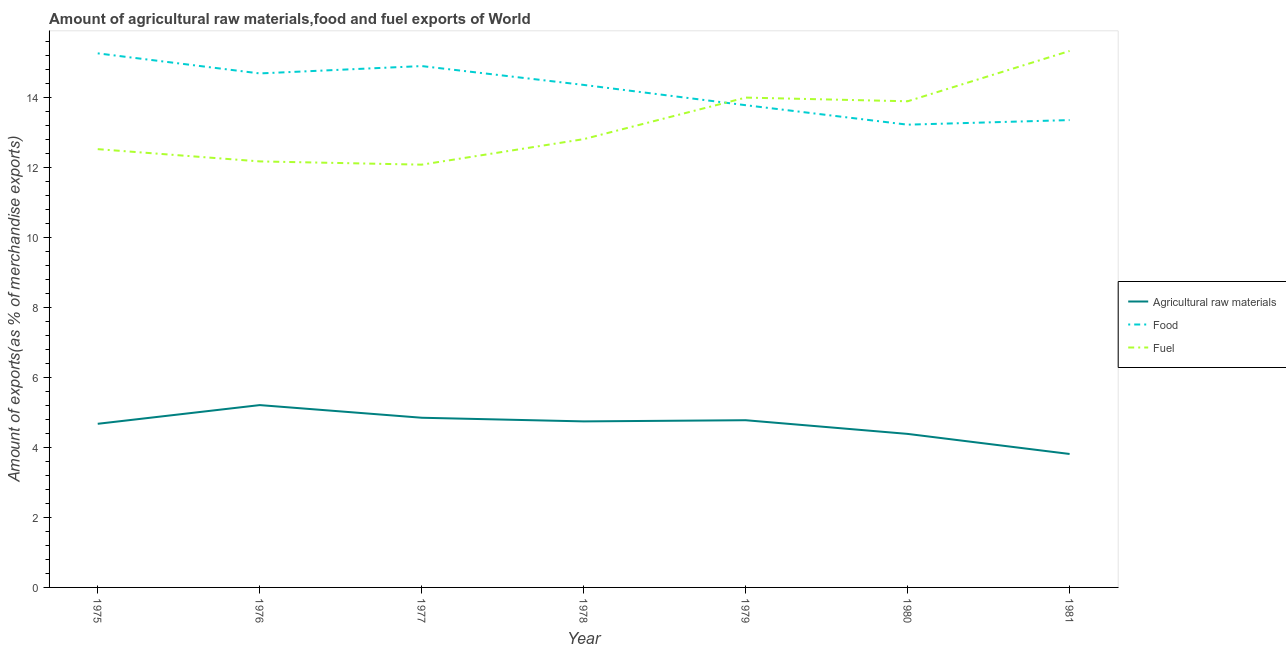Is the number of lines equal to the number of legend labels?
Give a very brief answer. Yes. What is the percentage of fuel exports in 1976?
Offer a very short reply. 12.16. Across all years, what is the maximum percentage of raw materials exports?
Your answer should be compact. 5.21. Across all years, what is the minimum percentage of fuel exports?
Offer a very short reply. 12.07. In which year was the percentage of raw materials exports maximum?
Give a very brief answer. 1976. What is the total percentage of raw materials exports in the graph?
Your answer should be very brief. 32.43. What is the difference between the percentage of food exports in 1977 and that in 1978?
Your response must be concise. 0.54. What is the difference between the percentage of raw materials exports in 1977 and the percentage of fuel exports in 1976?
Provide a short and direct response. -7.32. What is the average percentage of fuel exports per year?
Your response must be concise. 13.25. In the year 1981, what is the difference between the percentage of food exports and percentage of fuel exports?
Your answer should be compact. -1.97. In how many years, is the percentage of raw materials exports greater than 3.6 %?
Your answer should be very brief. 7. What is the ratio of the percentage of food exports in 1975 to that in 1976?
Provide a short and direct response. 1.04. Is the percentage of fuel exports in 1975 less than that in 1979?
Make the answer very short. Yes. Is the difference between the percentage of food exports in 1979 and 1980 greater than the difference between the percentage of raw materials exports in 1979 and 1980?
Your response must be concise. Yes. What is the difference between the highest and the second highest percentage of fuel exports?
Give a very brief answer. 1.33. What is the difference between the highest and the lowest percentage of raw materials exports?
Ensure brevity in your answer.  1.4. Is the sum of the percentage of fuel exports in 1978 and 1979 greater than the maximum percentage of food exports across all years?
Give a very brief answer. Yes. Is it the case that in every year, the sum of the percentage of raw materials exports and percentage of food exports is greater than the percentage of fuel exports?
Ensure brevity in your answer.  Yes. Does the percentage of raw materials exports monotonically increase over the years?
Your answer should be very brief. No. Is the percentage of fuel exports strictly greater than the percentage of raw materials exports over the years?
Keep it short and to the point. Yes. How many years are there in the graph?
Provide a short and direct response. 7. Does the graph contain grids?
Make the answer very short. No. Where does the legend appear in the graph?
Make the answer very short. Center right. How many legend labels are there?
Provide a short and direct response. 3. What is the title of the graph?
Give a very brief answer. Amount of agricultural raw materials,food and fuel exports of World. Does "Transport services" appear as one of the legend labels in the graph?
Offer a terse response. No. What is the label or title of the X-axis?
Your answer should be very brief. Year. What is the label or title of the Y-axis?
Make the answer very short. Amount of exports(as % of merchandise exports). What is the Amount of exports(as % of merchandise exports) of Agricultural raw materials in 1975?
Offer a terse response. 4.67. What is the Amount of exports(as % of merchandise exports) of Food in 1975?
Give a very brief answer. 15.25. What is the Amount of exports(as % of merchandise exports) in Fuel in 1975?
Keep it short and to the point. 12.51. What is the Amount of exports(as % of merchandise exports) in Agricultural raw materials in 1976?
Ensure brevity in your answer.  5.21. What is the Amount of exports(as % of merchandise exports) in Food in 1976?
Ensure brevity in your answer.  14.68. What is the Amount of exports(as % of merchandise exports) in Fuel in 1976?
Offer a very short reply. 12.16. What is the Amount of exports(as % of merchandise exports) in Agricultural raw materials in 1977?
Your response must be concise. 4.84. What is the Amount of exports(as % of merchandise exports) of Food in 1977?
Your answer should be very brief. 14.89. What is the Amount of exports(as % of merchandise exports) in Fuel in 1977?
Your response must be concise. 12.07. What is the Amount of exports(as % of merchandise exports) in Agricultural raw materials in 1978?
Offer a very short reply. 4.74. What is the Amount of exports(as % of merchandise exports) in Food in 1978?
Offer a terse response. 14.35. What is the Amount of exports(as % of merchandise exports) in Fuel in 1978?
Offer a terse response. 12.8. What is the Amount of exports(as % of merchandise exports) of Agricultural raw materials in 1979?
Keep it short and to the point. 4.77. What is the Amount of exports(as % of merchandise exports) in Food in 1979?
Your answer should be very brief. 13.77. What is the Amount of exports(as % of merchandise exports) in Fuel in 1979?
Offer a very short reply. 13.99. What is the Amount of exports(as % of merchandise exports) in Agricultural raw materials in 1980?
Your response must be concise. 4.38. What is the Amount of exports(as % of merchandise exports) in Food in 1980?
Offer a very short reply. 13.21. What is the Amount of exports(as % of merchandise exports) in Fuel in 1980?
Give a very brief answer. 13.88. What is the Amount of exports(as % of merchandise exports) in Agricultural raw materials in 1981?
Offer a very short reply. 3.81. What is the Amount of exports(as % of merchandise exports) in Food in 1981?
Your response must be concise. 13.34. What is the Amount of exports(as % of merchandise exports) in Fuel in 1981?
Make the answer very short. 15.32. Across all years, what is the maximum Amount of exports(as % of merchandise exports) of Agricultural raw materials?
Provide a short and direct response. 5.21. Across all years, what is the maximum Amount of exports(as % of merchandise exports) in Food?
Offer a very short reply. 15.25. Across all years, what is the maximum Amount of exports(as % of merchandise exports) in Fuel?
Provide a short and direct response. 15.32. Across all years, what is the minimum Amount of exports(as % of merchandise exports) in Agricultural raw materials?
Offer a terse response. 3.81. Across all years, what is the minimum Amount of exports(as % of merchandise exports) of Food?
Provide a succinct answer. 13.21. Across all years, what is the minimum Amount of exports(as % of merchandise exports) in Fuel?
Offer a terse response. 12.07. What is the total Amount of exports(as % of merchandise exports) of Agricultural raw materials in the graph?
Offer a terse response. 32.43. What is the total Amount of exports(as % of merchandise exports) in Food in the graph?
Offer a very short reply. 99.48. What is the total Amount of exports(as % of merchandise exports) in Fuel in the graph?
Provide a succinct answer. 92.73. What is the difference between the Amount of exports(as % of merchandise exports) of Agricultural raw materials in 1975 and that in 1976?
Ensure brevity in your answer.  -0.53. What is the difference between the Amount of exports(as % of merchandise exports) in Food in 1975 and that in 1976?
Your response must be concise. 0.57. What is the difference between the Amount of exports(as % of merchandise exports) in Fuel in 1975 and that in 1976?
Keep it short and to the point. 0.35. What is the difference between the Amount of exports(as % of merchandise exports) of Agricultural raw materials in 1975 and that in 1977?
Give a very brief answer. -0.17. What is the difference between the Amount of exports(as % of merchandise exports) of Food in 1975 and that in 1977?
Keep it short and to the point. 0.36. What is the difference between the Amount of exports(as % of merchandise exports) in Fuel in 1975 and that in 1977?
Provide a succinct answer. 0.44. What is the difference between the Amount of exports(as % of merchandise exports) in Agricultural raw materials in 1975 and that in 1978?
Your answer should be very brief. -0.07. What is the difference between the Amount of exports(as % of merchandise exports) in Food in 1975 and that in 1978?
Offer a very short reply. 0.9. What is the difference between the Amount of exports(as % of merchandise exports) in Fuel in 1975 and that in 1978?
Ensure brevity in your answer.  -0.29. What is the difference between the Amount of exports(as % of merchandise exports) in Agricultural raw materials in 1975 and that in 1979?
Provide a succinct answer. -0.1. What is the difference between the Amount of exports(as % of merchandise exports) of Food in 1975 and that in 1979?
Make the answer very short. 1.48. What is the difference between the Amount of exports(as % of merchandise exports) in Fuel in 1975 and that in 1979?
Offer a very short reply. -1.47. What is the difference between the Amount of exports(as % of merchandise exports) in Agricultural raw materials in 1975 and that in 1980?
Offer a terse response. 0.29. What is the difference between the Amount of exports(as % of merchandise exports) in Food in 1975 and that in 1980?
Ensure brevity in your answer.  2.04. What is the difference between the Amount of exports(as % of merchandise exports) of Fuel in 1975 and that in 1980?
Ensure brevity in your answer.  -1.37. What is the difference between the Amount of exports(as % of merchandise exports) in Agricultural raw materials in 1975 and that in 1981?
Ensure brevity in your answer.  0.86. What is the difference between the Amount of exports(as % of merchandise exports) in Food in 1975 and that in 1981?
Make the answer very short. 1.91. What is the difference between the Amount of exports(as % of merchandise exports) in Fuel in 1975 and that in 1981?
Give a very brief answer. -2.8. What is the difference between the Amount of exports(as % of merchandise exports) in Agricultural raw materials in 1976 and that in 1977?
Your answer should be very brief. 0.36. What is the difference between the Amount of exports(as % of merchandise exports) of Food in 1976 and that in 1977?
Offer a very short reply. -0.21. What is the difference between the Amount of exports(as % of merchandise exports) of Fuel in 1976 and that in 1977?
Provide a succinct answer. 0.09. What is the difference between the Amount of exports(as % of merchandise exports) of Agricultural raw materials in 1976 and that in 1978?
Ensure brevity in your answer.  0.47. What is the difference between the Amount of exports(as % of merchandise exports) in Food in 1976 and that in 1978?
Offer a terse response. 0.33. What is the difference between the Amount of exports(as % of merchandise exports) in Fuel in 1976 and that in 1978?
Provide a short and direct response. -0.64. What is the difference between the Amount of exports(as % of merchandise exports) in Agricultural raw materials in 1976 and that in 1979?
Offer a very short reply. 0.43. What is the difference between the Amount of exports(as % of merchandise exports) in Food in 1976 and that in 1979?
Offer a very short reply. 0.91. What is the difference between the Amount of exports(as % of merchandise exports) of Fuel in 1976 and that in 1979?
Give a very brief answer. -1.82. What is the difference between the Amount of exports(as % of merchandise exports) in Agricultural raw materials in 1976 and that in 1980?
Ensure brevity in your answer.  0.82. What is the difference between the Amount of exports(as % of merchandise exports) in Food in 1976 and that in 1980?
Keep it short and to the point. 1.46. What is the difference between the Amount of exports(as % of merchandise exports) in Fuel in 1976 and that in 1980?
Your answer should be very brief. -1.72. What is the difference between the Amount of exports(as % of merchandise exports) in Agricultural raw materials in 1976 and that in 1981?
Make the answer very short. 1.4. What is the difference between the Amount of exports(as % of merchandise exports) of Food in 1976 and that in 1981?
Provide a succinct answer. 1.33. What is the difference between the Amount of exports(as % of merchandise exports) of Fuel in 1976 and that in 1981?
Keep it short and to the point. -3.15. What is the difference between the Amount of exports(as % of merchandise exports) of Agricultural raw materials in 1977 and that in 1978?
Ensure brevity in your answer.  0.1. What is the difference between the Amount of exports(as % of merchandise exports) of Food in 1977 and that in 1978?
Offer a very short reply. 0.54. What is the difference between the Amount of exports(as % of merchandise exports) in Fuel in 1977 and that in 1978?
Offer a terse response. -0.73. What is the difference between the Amount of exports(as % of merchandise exports) of Agricultural raw materials in 1977 and that in 1979?
Provide a short and direct response. 0.07. What is the difference between the Amount of exports(as % of merchandise exports) in Food in 1977 and that in 1979?
Offer a very short reply. 1.12. What is the difference between the Amount of exports(as % of merchandise exports) in Fuel in 1977 and that in 1979?
Offer a very short reply. -1.92. What is the difference between the Amount of exports(as % of merchandise exports) of Agricultural raw materials in 1977 and that in 1980?
Ensure brevity in your answer.  0.46. What is the difference between the Amount of exports(as % of merchandise exports) of Food in 1977 and that in 1980?
Ensure brevity in your answer.  1.67. What is the difference between the Amount of exports(as % of merchandise exports) in Fuel in 1977 and that in 1980?
Offer a terse response. -1.81. What is the difference between the Amount of exports(as % of merchandise exports) in Agricultural raw materials in 1977 and that in 1981?
Offer a terse response. 1.03. What is the difference between the Amount of exports(as % of merchandise exports) in Food in 1977 and that in 1981?
Provide a short and direct response. 1.54. What is the difference between the Amount of exports(as % of merchandise exports) in Fuel in 1977 and that in 1981?
Your answer should be very brief. -3.25. What is the difference between the Amount of exports(as % of merchandise exports) of Agricultural raw materials in 1978 and that in 1979?
Provide a short and direct response. -0.03. What is the difference between the Amount of exports(as % of merchandise exports) of Food in 1978 and that in 1979?
Your answer should be very brief. 0.58. What is the difference between the Amount of exports(as % of merchandise exports) in Fuel in 1978 and that in 1979?
Your answer should be very brief. -1.19. What is the difference between the Amount of exports(as % of merchandise exports) in Agricultural raw materials in 1978 and that in 1980?
Offer a very short reply. 0.36. What is the difference between the Amount of exports(as % of merchandise exports) of Food in 1978 and that in 1980?
Offer a terse response. 1.14. What is the difference between the Amount of exports(as % of merchandise exports) in Fuel in 1978 and that in 1980?
Your answer should be very brief. -1.08. What is the difference between the Amount of exports(as % of merchandise exports) in Agricultural raw materials in 1978 and that in 1981?
Your response must be concise. 0.93. What is the difference between the Amount of exports(as % of merchandise exports) in Food in 1978 and that in 1981?
Make the answer very short. 1. What is the difference between the Amount of exports(as % of merchandise exports) in Fuel in 1978 and that in 1981?
Give a very brief answer. -2.52. What is the difference between the Amount of exports(as % of merchandise exports) of Agricultural raw materials in 1979 and that in 1980?
Ensure brevity in your answer.  0.39. What is the difference between the Amount of exports(as % of merchandise exports) in Food in 1979 and that in 1980?
Offer a very short reply. 0.56. What is the difference between the Amount of exports(as % of merchandise exports) of Fuel in 1979 and that in 1980?
Make the answer very short. 0.11. What is the difference between the Amount of exports(as % of merchandise exports) in Agricultural raw materials in 1979 and that in 1981?
Provide a succinct answer. 0.96. What is the difference between the Amount of exports(as % of merchandise exports) in Food in 1979 and that in 1981?
Your response must be concise. 0.42. What is the difference between the Amount of exports(as % of merchandise exports) in Fuel in 1979 and that in 1981?
Offer a very short reply. -1.33. What is the difference between the Amount of exports(as % of merchandise exports) in Agricultural raw materials in 1980 and that in 1981?
Offer a terse response. 0.57. What is the difference between the Amount of exports(as % of merchandise exports) in Food in 1980 and that in 1981?
Provide a succinct answer. -0.13. What is the difference between the Amount of exports(as % of merchandise exports) of Fuel in 1980 and that in 1981?
Your response must be concise. -1.44. What is the difference between the Amount of exports(as % of merchandise exports) of Agricultural raw materials in 1975 and the Amount of exports(as % of merchandise exports) of Food in 1976?
Provide a short and direct response. -10. What is the difference between the Amount of exports(as % of merchandise exports) of Agricultural raw materials in 1975 and the Amount of exports(as % of merchandise exports) of Fuel in 1976?
Give a very brief answer. -7.49. What is the difference between the Amount of exports(as % of merchandise exports) of Food in 1975 and the Amount of exports(as % of merchandise exports) of Fuel in 1976?
Your answer should be compact. 3.08. What is the difference between the Amount of exports(as % of merchandise exports) of Agricultural raw materials in 1975 and the Amount of exports(as % of merchandise exports) of Food in 1977?
Give a very brief answer. -10.21. What is the difference between the Amount of exports(as % of merchandise exports) in Agricultural raw materials in 1975 and the Amount of exports(as % of merchandise exports) in Fuel in 1977?
Your answer should be compact. -7.4. What is the difference between the Amount of exports(as % of merchandise exports) in Food in 1975 and the Amount of exports(as % of merchandise exports) in Fuel in 1977?
Offer a very short reply. 3.18. What is the difference between the Amount of exports(as % of merchandise exports) of Agricultural raw materials in 1975 and the Amount of exports(as % of merchandise exports) of Food in 1978?
Your response must be concise. -9.68. What is the difference between the Amount of exports(as % of merchandise exports) in Agricultural raw materials in 1975 and the Amount of exports(as % of merchandise exports) in Fuel in 1978?
Provide a succinct answer. -8.13. What is the difference between the Amount of exports(as % of merchandise exports) of Food in 1975 and the Amount of exports(as % of merchandise exports) of Fuel in 1978?
Ensure brevity in your answer.  2.45. What is the difference between the Amount of exports(as % of merchandise exports) of Agricultural raw materials in 1975 and the Amount of exports(as % of merchandise exports) of Food in 1979?
Make the answer very short. -9.1. What is the difference between the Amount of exports(as % of merchandise exports) in Agricultural raw materials in 1975 and the Amount of exports(as % of merchandise exports) in Fuel in 1979?
Give a very brief answer. -9.31. What is the difference between the Amount of exports(as % of merchandise exports) in Food in 1975 and the Amount of exports(as % of merchandise exports) in Fuel in 1979?
Your response must be concise. 1.26. What is the difference between the Amount of exports(as % of merchandise exports) of Agricultural raw materials in 1975 and the Amount of exports(as % of merchandise exports) of Food in 1980?
Ensure brevity in your answer.  -8.54. What is the difference between the Amount of exports(as % of merchandise exports) of Agricultural raw materials in 1975 and the Amount of exports(as % of merchandise exports) of Fuel in 1980?
Provide a short and direct response. -9.21. What is the difference between the Amount of exports(as % of merchandise exports) in Food in 1975 and the Amount of exports(as % of merchandise exports) in Fuel in 1980?
Your answer should be very brief. 1.37. What is the difference between the Amount of exports(as % of merchandise exports) of Agricultural raw materials in 1975 and the Amount of exports(as % of merchandise exports) of Food in 1981?
Provide a short and direct response. -8.67. What is the difference between the Amount of exports(as % of merchandise exports) in Agricultural raw materials in 1975 and the Amount of exports(as % of merchandise exports) in Fuel in 1981?
Offer a terse response. -10.64. What is the difference between the Amount of exports(as % of merchandise exports) of Food in 1975 and the Amount of exports(as % of merchandise exports) of Fuel in 1981?
Provide a succinct answer. -0.07. What is the difference between the Amount of exports(as % of merchandise exports) of Agricultural raw materials in 1976 and the Amount of exports(as % of merchandise exports) of Food in 1977?
Provide a short and direct response. -9.68. What is the difference between the Amount of exports(as % of merchandise exports) in Agricultural raw materials in 1976 and the Amount of exports(as % of merchandise exports) in Fuel in 1977?
Provide a short and direct response. -6.87. What is the difference between the Amount of exports(as % of merchandise exports) in Food in 1976 and the Amount of exports(as % of merchandise exports) in Fuel in 1977?
Give a very brief answer. 2.6. What is the difference between the Amount of exports(as % of merchandise exports) in Agricultural raw materials in 1976 and the Amount of exports(as % of merchandise exports) in Food in 1978?
Provide a succinct answer. -9.14. What is the difference between the Amount of exports(as % of merchandise exports) of Agricultural raw materials in 1976 and the Amount of exports(as % of merchandise exports) of Fuel in 1978?
Make the answer very short. -7.59. What is the difference between the Amount of exports(as % of merchandise exports) of Food in 1976 and the Amount of exports(as % of merchandise exports) of Fuel in 1978?
Provide a succinct answer. 1.88. What is the difference between the Amount of exports(as % of merchandise exports) of Agricultural raw materials in 1976 and the Amount of exports(as % of merchandise exports) of Food in 1979?
Provide a succinct answer. -8.56. What is the difference between the Amount of exports(as % of merchandise exports) in Agricultural raw materials in 1976 and the Amount of exports(as % of merchandise exports) in Fuel in 1979?
Your answer should be very brief. -8.78. What is the difference between the Amount of exports(as % of merchandise exports) in Food in 1976 and the Amount of exports(as % of merchandise exports) in Fuel in 1979?
Your response must be concise. 0.69. What is the difference between the Amount of exports(as % of merchandise exports) of Agricultural raw materials in 1976 and the Amount of exports(as % of merchandise exports) of Food in 1980?
Ensure brevity in your answer.  -8.01. What is the difference between the Amount of exports(as % of merchandise exports) in Agricultural raw materials in 1976 and the Amount of exports(as % of merchandise exports) in Fuel in 1980?
Keep it short and to the point. -8.67. What is the difference between the Amount of exports(as % of merchandise exports) of Food in 1976 and the Amount of exports(as % of merchandise exports) of Fuel in 1980?
Make the answer very short. 0.8. What is the difference between the Amount of exports(as % of merchandise exports) of Agricultural raw materials in 1976 and the Amount of exports(as % of merchandise exports) of Food in 1981?
Your answer should be very brief. -8.14. What is the difference between the Amount of exports(as % of merchandise exports) in Agricultural raw materials in 1976 and the Amount of exports(as % of merchandise exports) in Fuel in 1981?
Your answer should be compact. -10.11. What is the difference between the Amount of exports(as % of merchandise exports) in Food in 1976 and the Amount of exports(as % of merchandise exports) in Fuel in 1981?
Provide a short and direct response. -0.64. What is the difference between the Amount of exports(as % of merchandise exports) of Agricultural raw materials in 1977 and the Amount of exports(as % of merchandise exports) of Food in 1978?
Keep it short and to the point. -9.5. What is the difference between the Amount of exports(as % of merchandise exports) of Agricultural raw materials in 1977 and the Amount of exports(as % of merchandise exports) of Fuel in 1978?
Your answer should be compact. -7.95. What is the difference between the Amount of exports(as % of merchandise exports) of Food in 1977 and the Amount of exports(as % of merchandise exports) of Fuel in 1978?
Give a very brief answer. 2.09. What is the difference between the Amount of exports(as % of merchandise exports) of Agricultural raw materials in 1977 and the Amount of exports(as % of merchandise exports) of Food in 1979?
Give a very brief answer. -8.92. What is the difference between the Amount of exports(as % of merchandise exports) in Agricultural raw materials in 1977 and the Amount of exports(as % of merchandise exports) in Fuel in 1979?
Make the answer very short. -9.14. What is the difference between the Amount of exports(as % of merchandise exports) of Food in 1977 and the Amount of exports(as % of merchandise exports) of Fuel in 1979?
Ensure brevity in your answer.  0.9. What is the difference between the Amount of exports(as % of merchandise exports) of Agricultural raw materials in 1977 and the Amount of exports(as % of merchandise exports) of Food in 1980?
Give a very brief answer. -8.37. What is the difference between the Amount of exports(as % of merchandise exports) of Agricultural raw materials in 1977 and the Amount of exports(as % of merchandise exports) of Fuel in 1980?
Make the answer very short. -9.04. What is the difference between the Amount of exports(as % of merchandise exports) in Food in 1977 and the Amount of exports(as % of merchandise exports) in Fuel in 1980?
Provide a short and direct response. 1.01. What is the difference between the Amount of exports(as % of merchandise exports) of Agricultural raw materials in 1977 and the Amount of exports(as % of merchandise exports) of Food in 1981?
Your response must be concise. -8.5. What is the difference between the Amount of exports(as % of merchandise exports) of Agricultural raw materials in 1977 and the Amount of exports(as % of merchandise exports) of Fuel in 1981?
Offer a terse response. -10.47. What is the difference between the Amount of exports(as % of merchandise exports) of Food in 1977 and the Amount of exports(as % of merchandise exports) of Fuel in 1981?
Your answer should be very brief. -0.43. What is the difference between the Amount of exports(as % of merchandise exports) of Agricultural raw materials in 1978 and the Amount of exports(as % of merchandise exports) of Food in 1979?
Provide a succinct answer. -9.03. What is the difference between the Amount of exports(as % of merchandise exports) of Agricultural raw materials in 1978 and the Amount of exports(as % of merchandise exports) of Fuel in 1979?
Offer a terse response. -9.25. What is the difference between the Amount of exports(as % of merchandise exports) in Food in 1978 and the Amount of exports(as % of merchandise exports) in Fuel in 1979?
Provide a succinct answer. 0.36. What is the difference between the Amount of exports(as % of merchandise exports) in Agricultural raw materials in 1978 and the Amount of exports(as % of merchandise exports) in Food in 1980?
Offer a very short reply. -8.47. What is the difference between the Amount of exports(as % of merchandise exports) of Agricultural raw materials in 1978 and the Amount of exports(as % of merchandise exports) of Fuel in 1980?
Provide a short and direct response. -9.14. What is the difference between the Amount of exports(as % of merchandise exports) of Food in 1978 and the Amount of exports(as % of merchandise exports) of Fuel in 1980?
Ensure brevity in your answer.  0.47. What is the difference between the Amount of exports(as % of merchandise exports) in Agricultural raw materials in 1978 and the Amount of exports(as % of merchandise exports) in Food in 1981?
Offer a terse response. -8.6. What is the difference between the Amount of exports(as % of merchandise exports) of Agricultural raw materials in 1978 and the Amount of exports(as % of merchandise exports) of Fuel in 1981?
Your answer should be compact. -10.58. What is the difference between the Amount of exports(as % of merchandise exports) of Food in 1978 and the Amount of exports(as % of merchandise exports) of Fuel in 1981?
Your answer should be compact. -0.97. What is the difference between the Amount of exports(as % of merchandise exports) of Agricultural raw materials in 1979 and the Amount of exports(as % of merchandise exports) of Food in 1980?
Offer a terse response. -8.44. What is the difference between the Amount of exports(as % of merchandise exports) in Agricultural raw materials in 1979 and the Amount of exports(as % of merchandise exports) in Fuel in 1980?
Your response must be concise. -9.11. What is the difference between the Amount of exports(as % of merchandise exports) in Food in 1979 and the Amount of exports(as % of merchandise exports) in Fuel in 1980?
Your answer should be compact. -0.11. What is the difference between the Amount of exports(as % of merchandise exports) in Agricultural raw materials in 1979 and the Amount of exports(as % of merchandise exports) in Food in 1981?
Provide a short and direct response. -8.57. What is the difference between the Amount of exports(as % of merchandise exports) of Agricultural raw materials in 1979 and the Amount of exports(as % of merchandise exports) of Fuel in 1981?
Ensure brevity in your answer.  -10.54. What is the difference between the Amount of exports(as % of merchandise exports) of Food in 1979 and the Amount of exports(as % of merchandise exports) of Fuel in 1981?
Your answer should be very brief. -1.55. What is the difference between the Amount of exports(as % of merchandise exports) of Agricultural raw materials in 1980 and the Amount of exports(as % of merchandise exports) of Food in 1981?
Make the answer very short. -8.96. What is the difference between the Amount of exports(as % of merchandise exports) of Agricultural raw materials in 1980 and the Amount of exports(as % of merchandise exports) of Fuel in 1981?
Ensure brevity in your answer.  -10.93. What is the difference between the Amount of exports(as % of merchandise exports) of Food in 1980 and the Amount of exports(as % of merchandise exports) of Fuel in 1981?
Make the answer very short. -2.1. What is the average Amount of exports(as % of merchandise exports) in Agricultural raw materials per year?
Your answer should be very brief. 4.63. What is the average Amount of exports(as % of merchandise exports) of Food per year?
Provide a succinct answer. 14.21. What is the average Amount of exports(as % of merchandise exports) of Fuel per year?
Your answer should be very brief. 13.25. In the year 1975, what is the difference between the Amount of exports(as % of merchandise exports) of Agricultural raw materials and Amount of exports(as % of merchandise exports) of Food?
Ensure brevity in your answer.  -10.58. In the year 1975, what is the difference between the Amount of exports(as % of merchandise exports) of Agricultural raw materials and Amount of exports(as % of merchandise exports) of Fuel?
Ensure brevity in your answer.  -7.84. In the year 1975, what is the difference between the Amount of exports(as % of merchandise exports) in Food and Amount of exports(as % of merchandise exports) in Fuel?
Your answer should be compact. 2.73. In the year 1976, what is the difference between the Amount of exports(as % of merchandise exports) of Agricultural raw materials and Amount of exports(as % of merchandise exports) of Food?
Provide a succinct answer. -9.47. In the year 1976, what is the difference between the Amount of exports(as % of merchandise exports) of Agricultural raw materials and Amount of exports(as % of merchandise exports) of Fuel?
Offer a very short reply. -6.96. In the year 1976, what is the difference between the Amount of exports(as % of merchandise exports) of Food and Amount of exports(as % of merchandise exports) of Fuel?
Ensure brevity in your answer.  2.51. In the year 1977, what is the difference between the Amount of exports(as % of merchandise exports) of Agricultural raw materials and Amount of exports(as % of merchandise exports) of Food?
Your answer should be very brief. -10.04. In the year 1977, what is the difference between the Amount of exports(as % of merchandise exports) in Agricultural raw materials and Amount of exports(as % of merchandise exports) in Fuel?
Offer a very short reply. -7.23. In the year 1977, what is the difference between the Amount of exports(as % of merchandise exports) in Food and Amount of exports(as % of merchandise exports) in Fuel?
Give a very brief answer. 2.81. In the year 1978, what is the difference between the Amount of exports(as % of merchandise exports) in Agricultural raw materials and Amount of exports(as % of merchandise exports) in Food?
Make the answer very short. -9.61. In the year 1978, what is the difference between the Amount of exports(as % of merchandise exports) of Agricultural raw materials and Amount of exports(as % of merchandise exports) of Fuel?
Offer a terse response. -8.06. In the year 1978, what is the difference between the Amount of exports(as % of merchandise exports) in Food and Amount of exports(as % of merchandise exports) in Fuel?
Offer a very short reply. 1.55. In the year 1979, what is the difference between the Amount of exports(as % of merchandise exports) of Agricultural raw materials and Amount of exports(as % of merchandise exports) of Food?
Your answer should be very brief. -8.99. In the year 1979, what is the difference between the Amount of exports(as % of merchandise exports) in Agricultural raw materials and Amount of exports(as % of merchandise exports) in Fuel?
Offer a terse response. -9.21. In the year 1979, what is the difference between the Amount of exports(as % of merchandise exports) in Food and Amount of exports(as % of merchandise exports) in Fuel?
Your answer should be very brief. -0.22. In the year 1980, what is the difference between the Amount of exports(as % of merchandise exports) in Agricultural raw materials and Amount of exports(as % of merchandise exports) in Food?
Provide a succinct answer. -8.83. In the year 1980, what is the difference between the Amount of exports(as % of merchandise exports) of Agricultural raw materials and Amount of exports(as % of merchandise exports) of Fuel?
Your response must be concise. -9.5. In the year 1980, what is the difference between the Amount of exports(as % of merchandise exports) in Food and Amount of exports(as % of merchandise exports) in Fuel?
Provide a succinct answer. -0.67. In the year 1981, what is the difference between the Amount of exports(as % of merchandise exports) of Agricultural raw materials and Amount of exports(as % of merchandise exports) of Food?
Offer a terse response. -9.53. In the year 1981, what is the difference between the Amount of exports(as % of merchandise exports) in Agricultural raw materials and Amount of exports(as % of merchandise exports) in Fuel?
Your response must be concise. -11.51. In the year 1981, what is the difference between the Amount of exports(as % of merchandise exports) in Food and Amount of exports(as % of merchandise exports) in Fuel?
Keep it short and to the point. -1.97. What is the ratio of the Amount of exports(as % of merchandise exports) of Agricultural raw materials in 1975 to that in 1976?
Your answer should be very brief. 0.9. What is the ratio of the Amount of exports(as % of merchandise exports) in Food in 1975 to that in 1976?
Offer a very short reply. 1.04. What is the ratio of the Amount of exports(as % of merchandise exports) in Fuel in 1975 to that in 1976?
Your answer should be very brief. 1.03. What is the ratio of the Amount of exports(as % of merchandise exports) of Agricultural raw materials in 1975 to that in 1977?
Keep it short and to the point. 0.96. What is the ratio of the Amount of exports(as % of merchandise exports) of Food in 1975 to that in 1977?
Your response must be concise. 1.02. What is the ratio of the Amount of exports(as % of merchandise exports) in Fuel in 1975 to that in 1977?
Your answer should be compact. 1.04. What is the ratio of the Amount of exports(as % of merchandise exports) in Agricultural raw materials in 1975 to that in 1978?
Your answer should be very brief. 0.99. What is the ratio of the Amount of exports(as % of merchandise exports) of Food in 1975 to that in 1978?
Offer a terse response. 1.06. What is the ratio of the Amount of exports(as % of merchandise exports) of Fuel in 1975 to that in 1978?
Provide a succinct answer. 0.98. What is the ratio of the Amount of exports(as % of merchandise exports) in Agricultural raw materials in 1975 to that in 1979?
Your response must be concise. 0.98. What is the ratio of the Amount of exports(as % of merchandise exports) in Food in 1975 to that in 1979?
Give a very brief answer. 1.11. What is the ratio of the Amount of exports(as % of merchandise exports) in Fuel in 1975 to that in 1979?
Your answer should be very brief. 0.89. What is the ratio of the Amount of exports(as % of merchandise exports) of Agricultural raw materials in 1975 to that in 1980?
Your answer should be very brief. 1.07. What is the ratio of the Amount of exports(as % of merchandise exports) in Food in 1975 to that in 1980?
Give a very brief answer. 1.15. What is the ratio of the Amount of exports(as % of merchandise exports) in Fuel in 1975 to that in 1980?
Your answer should be very brief. 0.9. What is the ratio of the Amount of exports(as % of merchandise exports) of Agricultural raw materials in 1975 to that in 1981?
Your answer should be very brief. 1.23. What is the ratio of the Amount of exports(as % of merchandise exports) of Food in 1975 to that in 1981?
Your answer should be compact. 1.14. What is the ratio of the Amount of exports(as % of merchandise exports) in Fuel in 1975 to that in 1981?
Your response must be concise. 0.82. What is the ratio of the Amount of exports(as % of merchandise exports) in Agricultural raw materials in 1976 to that in 1977?
Ensure brevity in your answer.  1.07. What is the ratio of the Amount of exports(as % of merchandise exports) of Food in 1976 to that in 1977?
Give a very brief answer. 0.99. What is the ratio of the Amount of exports(as % of merchandise exports) in Fuel in 1976 to that in 1977?
Keep it short and to the point. 1.01. What is the ratio of the Amount of exports(as % of merchandise exports) in Agricultural raw materials in 1976 to that in 1978?
Your response must be concise. 1.1. What is the ratio of the Amount of exports(as % of merchandise exports) in Food in 1976 to that in 1978?
Provide a short and direct response. 1.02. What is the ratio of the Amount of exports(as % of merchandise exports) of Fuel in 1976 to that in 1978?
Provide a succinct answer. 0.95. What is the ratio of the Amount of exports(as % of merchandise exports) of Agricultural raw materials in 1976 to that in 1979?
Offer a terse response. 1.09. What is the ratio of the Amount of exports(as % of merchandise exports) of Food in 1976 to that in 1979?
Your answer should be very brief. 1.07. What is the ratio of the Amount of exports(as % of merchandise exports) in Fuel in 1976 to that in 1979?
Provide a succinct answer. 0.87. What is the ratio of the Amount of exports(as % of merchandise exports) of Agricultural raw materials in 1976 to that in 1980?
Provide a short and direct response. 1.19. What is the ratio of the Amount of exports(as % of merchandise exports) of Food in 1976 to that in 1980?
Provide a short and direct response. 1.11. What is the ratio of the Amount of exports(as % of merchandise exports) of Fuel in 1976 to that in 1980?
Your answer should be very brief. 0.88. What is the ratio of the Amount of exports(as % of merchandise exports) of Agricultural raw materials in 1976 to that in 1981?
Ensure brevity in your answer.  1.37. What is the ratio of the Amount of exports(as % of merchandise exports) of Food in 1976 to that in 1981?
Your response must be concise. 1.1. What is the ratio of the Amount of exports(as % of merchandise exports) in Fuel in 1976 to that in 1981?
Make the answer very short. 0.79. What is the ratio of the Amount of exports(as % of merchandise exports) of Agricultural raw materials in 1977 to that in 1978?
Provide a succinct answer. 1.02. What is the ratio of the Amount of exports(as % of merchandise exports) of Food in 1977 to that in 1978?
Your answer should be compact. 1.04. What is the ratio of the Amount of exports(as % of merchandise exports) in Fuel in 1977 to that in 1978?
Your answer should be compact. 0.94. What is the ratio of the Amount of exports(as % of merchandise exports) of Agricultural raw materials in 1977 to that in 1979?
Ensure brevity in your answer.  1.01. What is the ratio of the Amount of exports(as % of merchandise exports) of Food in 1977 to that in 1979?
Provide a short and direct response. 1.08. What is the ratio of the Amount of exports(as % of merchandise exports) of Fuel in 1977 to that in 1979?
Ensure brevity in your answer.  0.86. What is the ratio of the Amount of exports(as % of merchandise exports) of Agricultural raw materials in 1977 to that in 1980?
Offer a very short reply. 1.11. What is the ratio of the Amount of exports(as % of merchandise exports) of Food in 1977 to that in 1980?
Your answer should be compact. 1.13. What is the ratio of the Amount of exports(as % of merchandise exports) in Fuel in 1977 to that in 1980?
Provide a succinct answer. 0.87. What is the ratio of the Amount of exports(as % of merchandise exports) of Agricultural raw materials in 1977 to that in 1981?
Make the answer very short. 1.27. What is the ratio of the Amount of exports(as % of merchandise exports) in Food in 1977 to that in 1981?
Your answer should be very brief. 1.12. What is the ratio of the Amount of exports(as % of merchandise exports) of Fuel in 1977 to that in 1981?
Your response must be concise. 0.79. What is the ratio of the Amount of exports(as % of merchandise exports) of Food in 1978 to that in 1979?
Offer a very short reply. 1.04. What is the ratio of the Amount of exports(as % of merchandise exports) of Fuel in 1978 to that in 1979?
Ensure brevity in your answer.  0.92. What is the ratio of the Amount of exports(as % of merchandise exports) in Agricultural raw materials in 1978 to that in 1980?
Provide a short and direct response. 1.08. What is the ratio of the Amount of exports(as % of merchandise exports) of Food in 1978 to that in 1980?
Ensure brevity in your answer.  1.09. What is the ratio of the Amount of exports(as % of merchandise exports) of Fuel in 1978 to that in 1980?
Offer a terse response. 0.92. What is the ratio of the Amount of exports(as % of merchandise exports) in Agricultural raw materials in 1978 to that in 1981?
Keep it short and to the point. 1.24. What is the ratio of the Amount of exports(as % of merchandise exports) in Food in 1978 to that in 1981?
Your answer should be very brief. 1.08. What is the ratio of the Amount of exports(as % of merchandise exports) in Fuel in 1978 to that in 1981?
Offer a terse response. 0.84. What is the ratio of the Amount of exports(as % of merchandise exports) in Agricultural raw materials in 1979 to that in 1980?
Keep it short and to the point. 1.09. What is the ratio of the Amount of exports(as % of merchandise exports) of Food in 1979 to that in 1980?
Keep it short and to the point. 1.04. What is the ratio of the Amount of exports(as % of merchandise exports) in Fuel in 1979 to that in 1980?
Ensure brevity in your answer.  1.01. What is the ratio of the Amount of exports(as % of merchandise exports) in Agricultural raw materials in 1979 to that in 1981?
Ensure brevity in your answer.  1.25. What is the ratio of the Amount of exports(as % of merchandise exports) of Food in 1979 to that in 1981?
Provide a short and direct response. 1.03. What is the ratio of the Amount of exports(as % of merchandise exports) of Fuel in 1979 to that in 1981?
Your response must be concise. 0.91. What is the ratio of the Amount of exports(as % of merchandise exports) in Agricultural raw materials in 1980 to that in 1981?
Provide a short and direct response. 1.15. What is the ratio of the Amount of exports(as % of merchandise exports) in Food in 1980 to that in 1981?
Offer a terse response. 0.99. What is the ratio of the Amount of exports(as % of merchandise exports) in Fuel in 1980 to that in 1981?
Provide a short and direct response. 0.91. What is the difference between the highest and the second highest Amount of exports(as % of merchandise exports) in Agricultural raw materials?
Your answer should be very brief. 0.36. What is the difference between the highest and the second highest Amount of exports(as % of merchandise exports) of Food?
Provide a short and direct response. 0.36. What is the difference between the highest and the second highest Amount of exports(as % of merchandise exports) of Fuel?
Ensure brevity in your answer.  1.33. What is the difference between the highest and the lowest Amount of exports(as % of merchandise exports) of Agricultural raw materials?
Give a very brief answer. 1.4. What is the difference between the highest and the lowest Amount of exports(as % of merchandise exports) in Food?
Your answer should be compact. 2.04. What is the difference between the highest and the lowest Amount of exports(as % of merchandise exports) in Fuel?
Your answer should be compact. 3.25. 